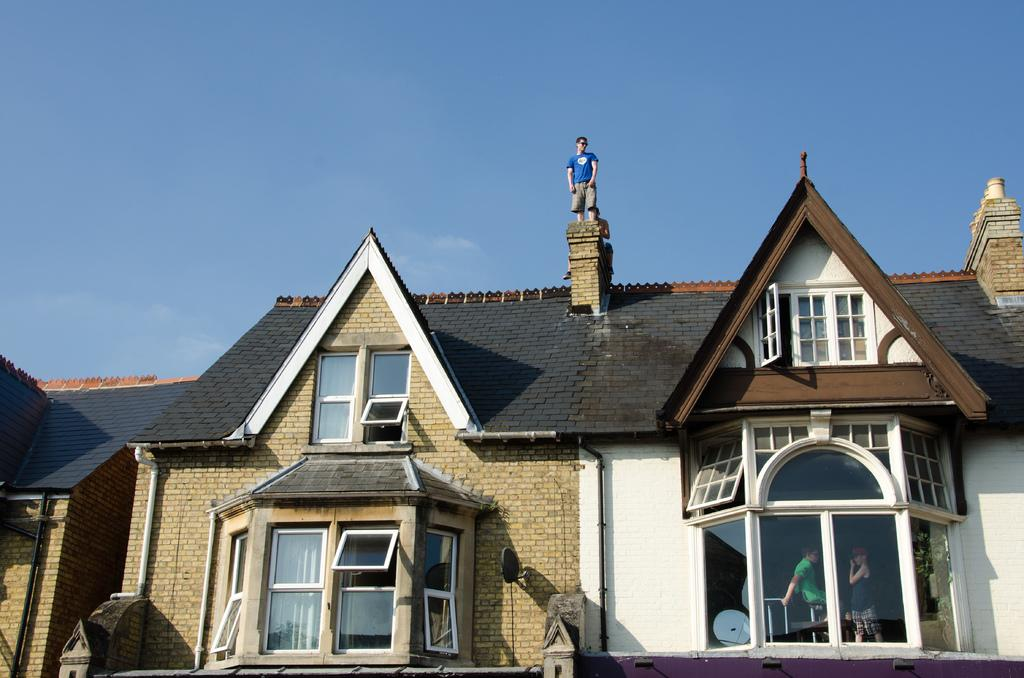What type of structures are present in the image? There are houses in the image. What feature can be seen on the houses? There are windows visible in the image. How many people are in the image? There are three persons in the image. What is the color of the sky in the background of the image? The sky is blue in the background of the image. Based on the sky color, when do you think the image was taken? The image was likely taken during the day. What is the tendency of the cat to jump over the water in the image? There is no cat or water present in the image, so it is not possible to determine any tendencies related to them. 